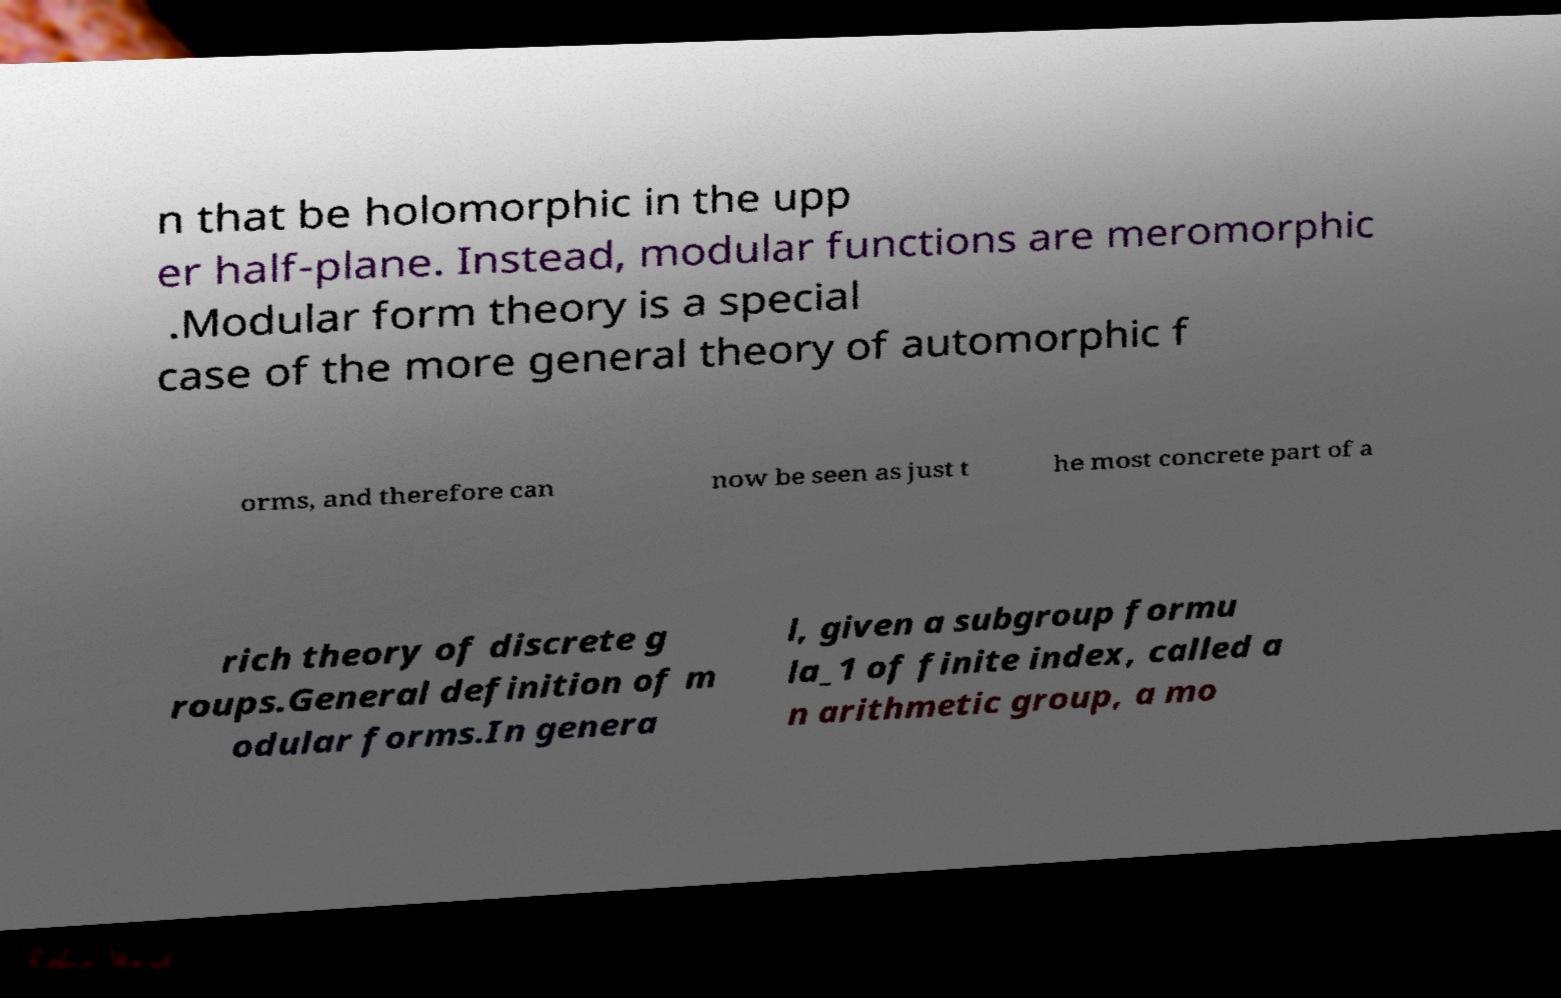Could you extract and type out the text from this image? n that be holomorphic in the upp er half-plane. Instead, modular functions are meromorphic .Modular form theory is a special case of the more general theory of automorphic f orms, and therefore can now be seen as just t he most concrete part of a rich theory of discrete g roups.General definition of m odular forms.In genera l, given a subgroup formu la_1 of finite index, called a n arithmetic group, a mo 